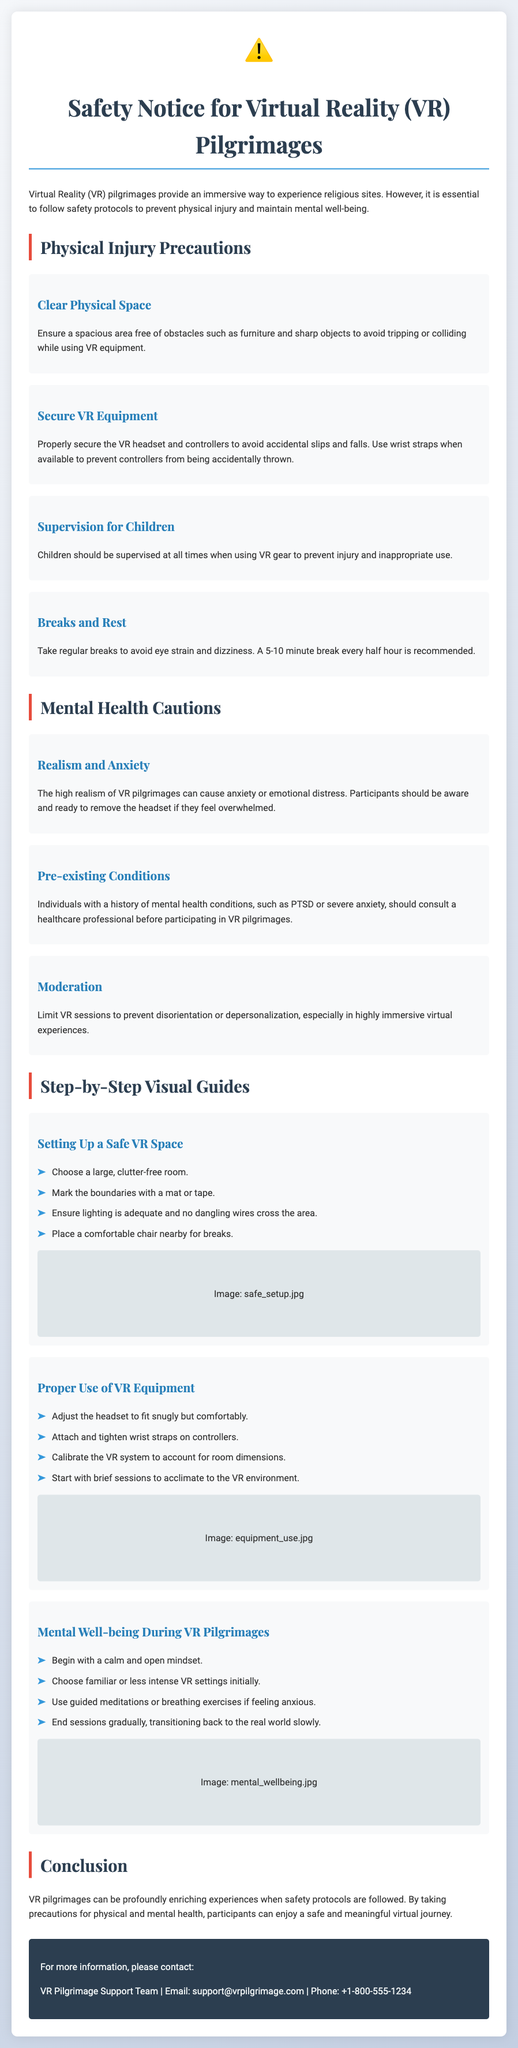What should be ensured in the area for VR use? The document states to ensure a spacious area free of obstacles such as furniture and sharp objects.
Answer: spacious area free of obstacles How often should breaks be taken during VR sessions? The recommendation in the document is to take a 5-10 minute break every half hour.
Answer: 5-10 minutes every half hour What is advised for children using VR equipment? The document advises that children should be supervised at all times when using VR gear.
Answer: supervised at all times What is one mental health caution listed in the document? The document mentions the high realism of VR pilgrimages can cause anxiety or emotional distress.
Answer: anxiety or emotional distress What should individuals with a history of mental health conditions do before participating in VR pilgrimages? The document recommends that they should consult a healthcare professional.
Answer: consult a healthcare professional Which step involves ensuring adequate lighting? This is part of setting up a safe VR space where lighting must be adequate.
Answer: adequate lighting What color is the warning icon in the document? The warning icon is colored in a way that suggests caution, specifically in red.
Answer: red What should be used to secure controllers? The document suggests using wrist straps when available to prevent controllers from being accidentally thrown.
Answer: wrist straps What should be done if someone feels overwhelmed during a VR session? The document advises participants should be ready to remove the headset.
Answer: remove the headset 